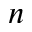<formula> <loc_0><loc_0><loc_500><loc_500>n</formula> 